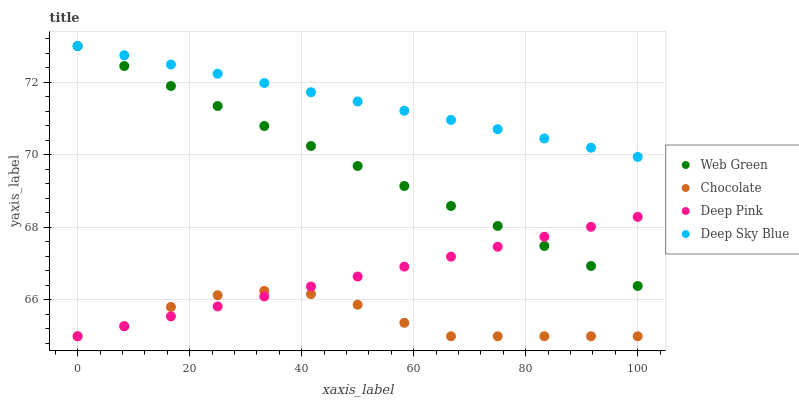Does Chocolate have the minimum area under the curve?
Answer yes or no. Yes. Does Deep Sky Blue have the maximum area under the curve?
Answer yes or no. Yes. Does Web Green have the minimum area under the curve?
Answer yes or no. No. Does Web Green have the maximum area under the curve?
Answer yes or no. No. Is Deep Pink the smoothest?
Answer yes or no. Yes. Is Chocolate the roughest?
Answer yes or no. Yes. Is Deep Sky Blue the smoothest?
Answer yes or no. No. Is Deep Sky Blue the roughest?
Answer yes or no. No. Does Deep Pink have the lowest value?
Answer yes or no. Yes. Does Web Green have the lowest value?
Answer yes or no. No. Does Web Green have the highest value?
Answer yes or no. Yes. Does Chocolate have the highest value?
Answer yes or no. No. Is Deep Pink less than Deep Sky Blue?
Answer yes or no. Yes. Is Deep Sky Blue greater than Chocolate?
Answer yes or no. Yes. Does Web Green intersect Deep Pink?
Answer yes or no. Yes. Is Web Green less than Deep Pink?
Answer yes or no. No. Is Web Green greater than Deep Pink?
Answer yes or no. No. Does Deep Pink intersect Deep Sky Blue?
Answer yes or no. No. 